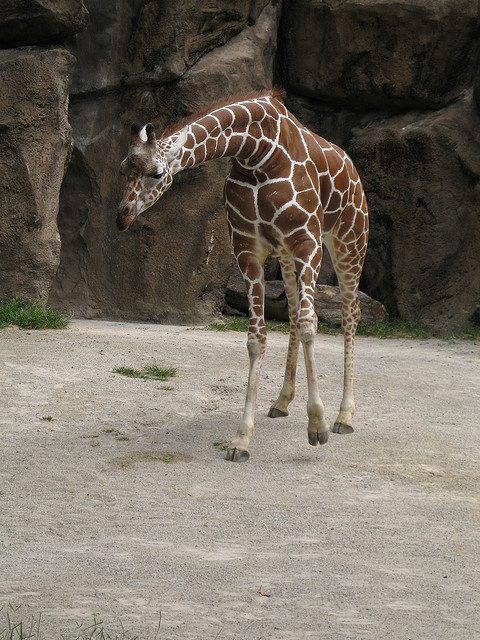Describe the objects in this image and their specific colors. I can see a giraffe in black, gray, and maroon tones in this image. 